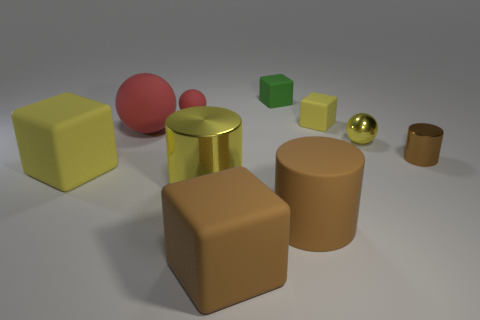Subtract all cylinders. How many objects are left? 7 Subtract all large brown cubes. Subtract all red things. How many objects are left? 7 Add 2 brown metallic objects. How many brown metallic objects are left? 3 Add 7 green rubber blocks. How many green rubber blocks exist? 8 Subtract 0 cyan spheres. How many objects are left? 10 